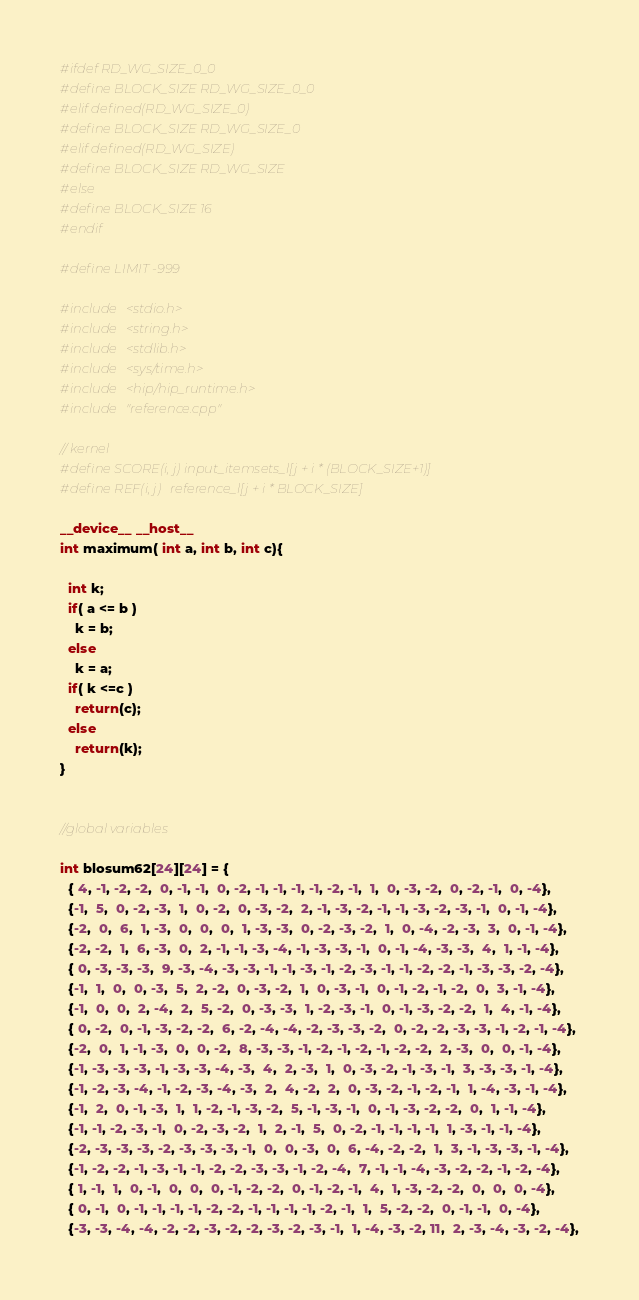<code> <loc_0><loc_0><loc_500><loc_500><_Cuda_>#ifdef RD_WG_SIZE_0_0
#define BLOCK_SIZE RD_WG_SIZE_0_0
#elif defined(RD_WG_SIZE_0)
#define BLOCK_SIZE RD_WG_SIZE_0
#elif defined(RD_WG_SIZE)
#define BLOCK_SIZE RD_WG_SIZE
#else
#define BLOCK_SIZE 16
#endif

#define LIMIT -999

#include <stdio.h>
#include <string.h>
#include <stdlib.h>
#include <sys/time.h>
#include <hip/hip_runtime.h>
#include "reference.cpp"

// kernel 
#define SCORE(i, j) input_itemsets_l[j + i * (BLOCK_SIZE+1)]
#define REF(i, j)   reference_l[j + i * BLOCK_SIZE]

__device__ __host__
int maximum( int a, int b, int c){

  int k;
  if( a <= b )
    k = b;
  else 
    k = a;
  if( k <=c )
    return(c);
  else
    return(k);
}


//global variables

int blosum62[24][24] = {
  { 4, -1, -2, -2,  0, -1, -1,  0, -2, -1, -1, -1, -1, -2, -1,  1,  0, -3, -2,  0, -2, -1,  0, -4},
  {-1,  5,  0, -2, -3,  1,  0, -2,  0, -3, -2,  2, -1, -3, -2, -1, -1, -3, -2, -3, -1,  0, -1, -4},
  {-2,  0,  6,  1, -3,  0,  0,  0,  1, -3, -3,  0, -2, -3, -2,  1,  0, -4, -2, -3,  3,  0, -1, -4},
  {-2, -2,  1,  6, -3,  0,  2, -1, -1, -3, -4, -1, -3, -3, -1,  0, -1, -4, -3, -3,  4,  1, -1, -4},
  { 0, -3, -3, -3,  9, -3, -4, -3, -3, -1, -1, -3, -1, -2, -3, -1, -1, -2, -2, -1, -3, -3, -2, -4},
  {-1,  1,  0,  0, -3,  5,  2, -2,  0, -3, -2,  1,  0, -3, -1,  0, -1, -2, -1, -2,  0,  3, -1, -4},
  {-1,  0,  0,  2, -4,  2,  5, -2,  0, -3, -3,  1, -2, -3, -1,  0, -1, -3, -2, -2,  1,  4, -1, -4},
  { 0, -2,  0, -1, -3, -2, -2,  6, -2, -4, -4, -2, -3, -3, -2,  0, -2, -2, -3, -3, -1, -2, -1, -4},
  {-2,  0,  1, -1, -3,  0,  0, -2,  8, -3, -3, -1, -2, -1, -2, -1, -2, -2,  2, -3,  0,  0, -1, -4},
  {-1, -3, -3, -3, -1, -3, -3, -4, -3,  4,  2, -3,  1,  0, -3, -2, -1, -3, -1,  3, -3, -3, -1, -4},
  {-1, -2, -3, -4, -1, -2, -3, -4, -3,  2,  4, -2,  2,  0, -3, -2, -1, -2, -1,  1, -4, -3, -1, -4},
  {-1,  2,  0, -1, -3,  1,  1, -2, -1, -3, -2,  5, -1, -3, -1,  0, -1, -3, -2, -2,  0,  1, -1, -4},
  {-1, -1, -2, -3, -1,  0, -2, -3, -2,  1,  2, -1,  5,  0, -2, -1, -1, -1, -1,  1, -3, -1, -1, -4},
  {-2, -3, -3, -3, -2, -3, -3, -3, -1,  0,  0, -3,  0,  6, -4, -2, -2,  1,  3, -1, -3, -3, -1, -4},
  {-1, -2, -2, -1, -3, -1, -1, -2, -2, -3, -3, -1, -2, -4,  7, -1, -1, -4, -3, -2, -2, -1, -2, -4},
  { 1, -1,  1,  0, -1,  0,  0,  0, -1, -2, -2,  0, -1, -2, -1,  4,  1, -3, -2, -2,  0,  0,  0, -4},
  { 0, -1,  0, -1, -1, -1, -1, -2, -2, -1, -1, -1, -1, -2, -1,  1,  5, -2, -2,  0, -1, -1,  0, -4},
  {-3, -3, -4, -4, -2, -2, -3, -2, -2, -3, -2, -3, -1,  1, -4, -3, -2, 11,  2, -3, -4, -3, -2, -4},</code> 